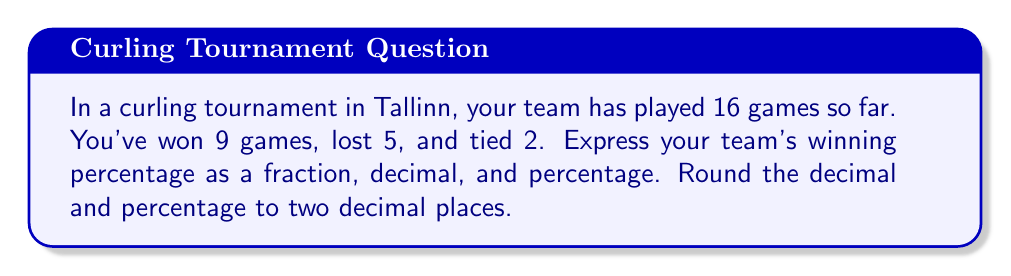Help me with this question. To solve this problem, we need to follow these steps:

1. Calculate the number of wins:
   We already know this is 9 games.

2. Calculate the total number of games that count towards the winning percentage:
   In curling, ties typically count as half a win. So:
   Total games = Wins + Losses + (Ties ÷ 2)
   $$ 16 = 9 + 5 + (2 \div 2) = 9 + 5 + 1 = 15 $$

3. Calculate the winning percentage as a fraction:
   $$ \text{Winning Percentage} = \frac{\text{Wins} + (\text{Ties} \div 2)}{\text{Total Games}} = \frac{9 + 1}{15} = \frac{10}{15} $$

4. Simplify the fraction:
   $$ \frac{10}{15} = \frac{2}{3} $$

5. Convert the fraction to a decimal:
   $$ \frac{2}{3} \approx 0.6666... \approx 0.67 \text{ (rounded to two decimal places)} $$

6. Convert the decimal to a percentage:
   $$ 0.67 \times 100\% = 67.00\% $$
Answer: Fraction: $\frac{2}{3}$
Decimal: $0.67$
Percentage: $67.00\%$ 